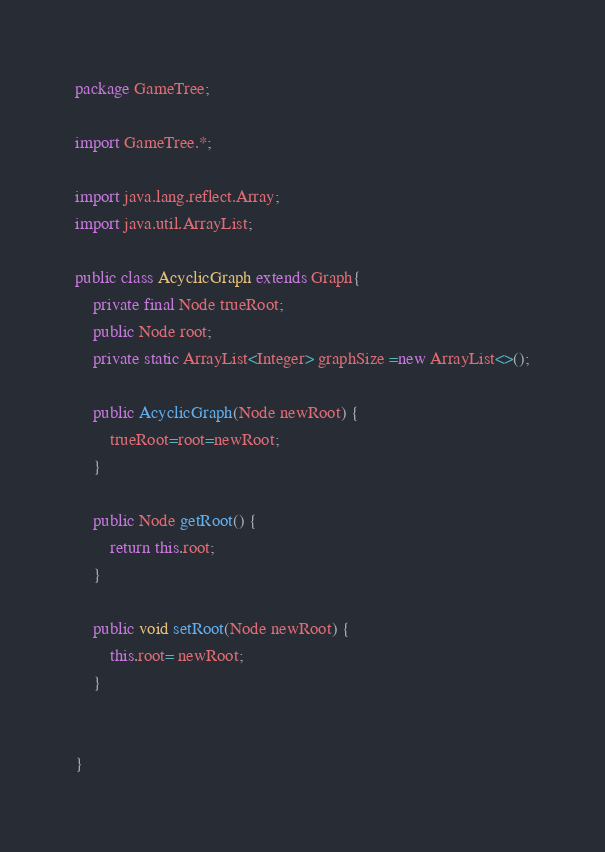<code> <loc_0><loc_0><loc_500><loc_500><_Java_>package GameTree;

import GameTree.*;

import java.lang.reflect.Array;
import java.util.ArrayList;

public class AcyclicGraph extends Graph{
    private final Node trueRoot;
    public Node root;
    private static ArrayList<Integer> graphSize =new ArrayList<>();

    public AcyclicGraph(Node newRoot) {
        trueRoot=root=newRoot;
    }

    public Node getRoot() {
        return this.root;
    }

    public void setRoot(Node newRoot) {
        this.root= newRoot;
    }


}

</code> 